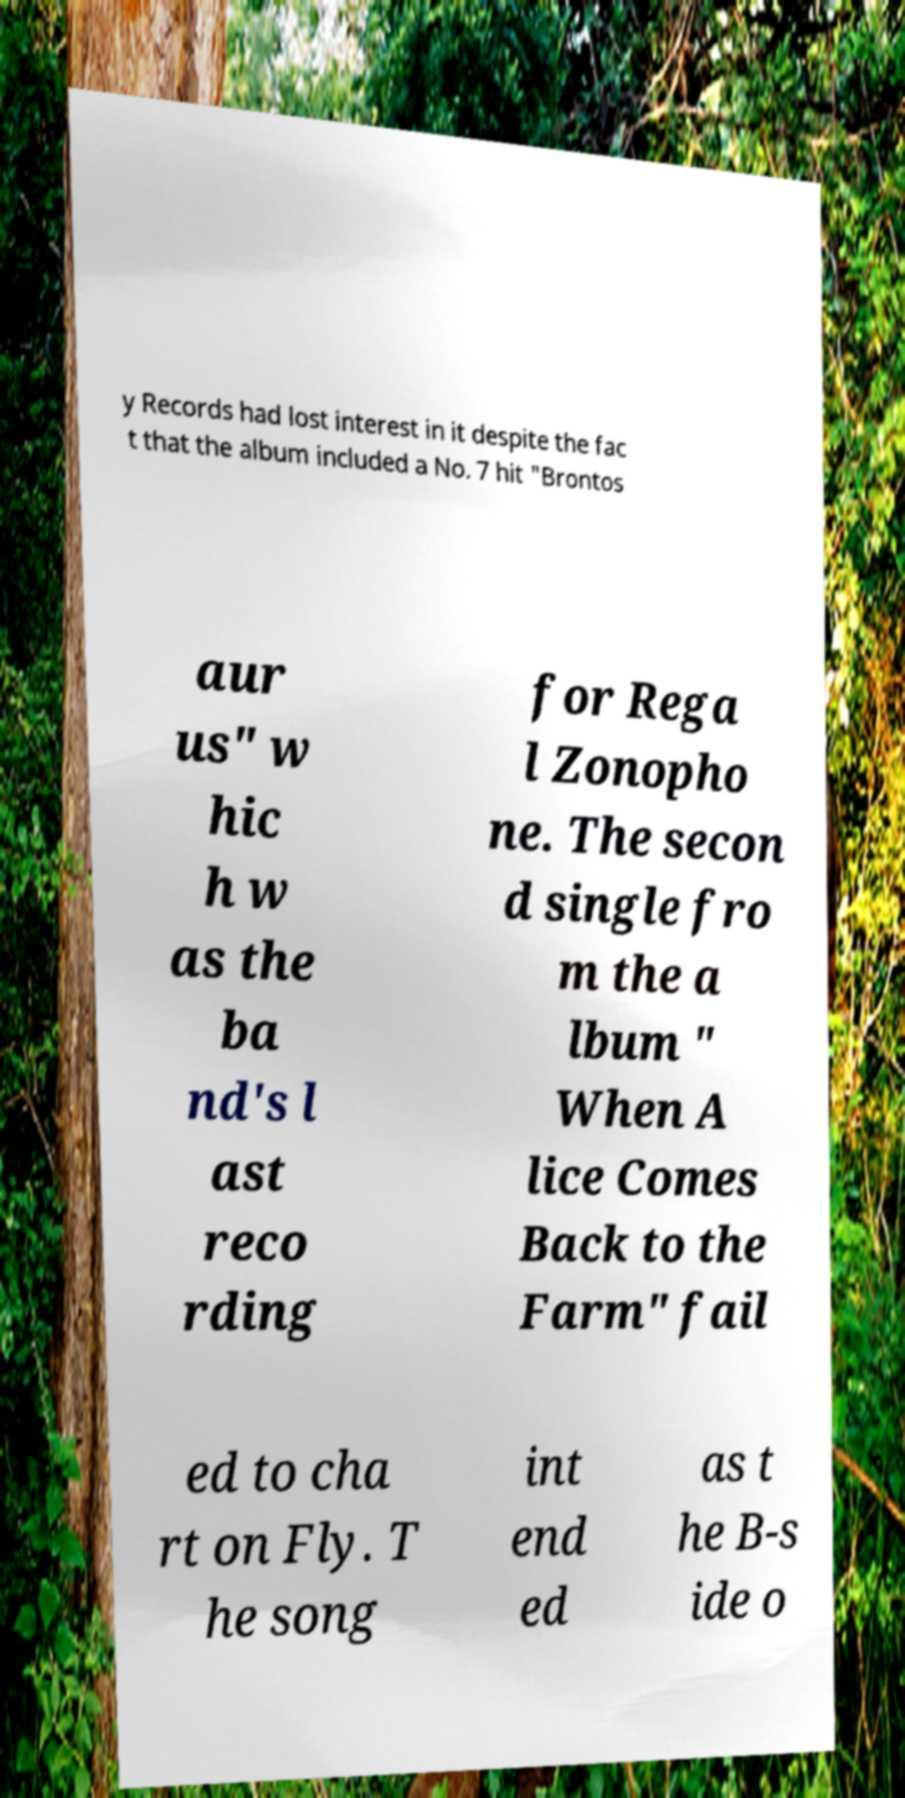Please identify and transcribe the text found in this image. y Records had lost interest in it despite the fac t that the album included a No. 7 hit "Brontos aur us" w hic h w as the ba nd's l ast reco rding for Rega l Zonopho ne. The secon d single fro m the a lbum " When A lice Comes Back to the Farm" fail ed to cha rt on Fly. T he song int end ed as t he B-s ide o 